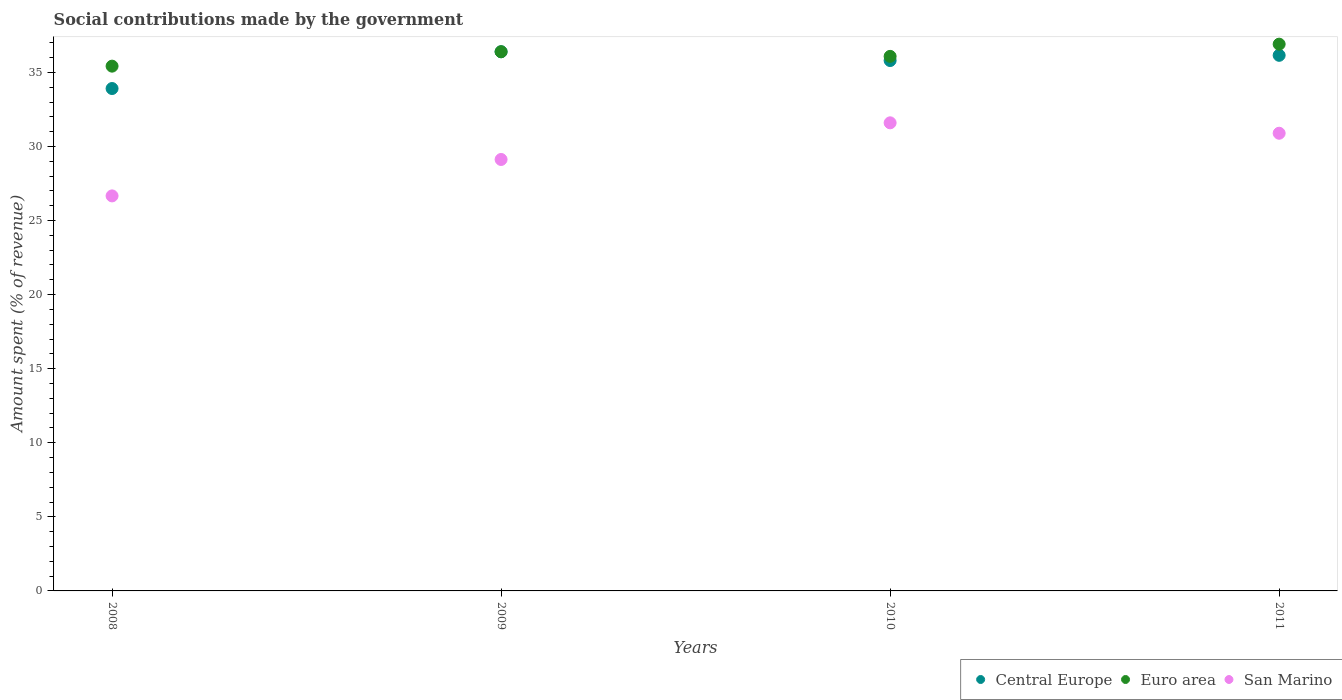What is the amount spent (in %) on social contributions in Central Europe in 2011?
Your answer should be very brief. 36.15. Across all years, what is the maximum amount spent (in %) on social contributions in Euro area?
Keep it short and to the point. 36.9. Across all years, what is the minimum amount spent (in %) on social contributions in Central Europe?
Offer a terse response. 33.91. In which year was the amount spent (in %) on social contributions in Euro area maximum?
Provide a short and direct response. 2011. In which year was the amount spent (in %) on social contributions in Euro area minimum?
Make the answer very short. 2008. What is the total amount spent (in %) on social contributions in Euro area in the graph?
Make the answer very short. 144.8. What is the difference between the amount spent (in %) on social contributions in San Marino in 2009 and that in 2011?
Provide a succinct answer. -1.77. What is the difference between the amount spent (in %) on social contributions in Central Europe in 2011 and the amount spent (in %) on social contributions in Euro area in 2010?
Offer a terse response. 0.07. What is the average amount spent (in %) on social contributions in San Marino per year?
Ensure brevity in your answer.  29.57. In the year 2008, what is the difference between the amount spent (in %) on social contributions in San Marino and amount spent (in %) on social contributions in Central Europe?
Your response must be concise. -7.25. What is the ratio of the amount spent (in %) on social contributions in Euro area in 2009 to that in 2011?
Give a very brief answer. 0.99. Is the amount spent (in %) on social contributions in San Marino in 2010 less than that in 2011?
Make the answer very short. No. Is the difference between the amount spent (in %) on social contributions in San Marino in 2009 and 2011 greater than the difference between the amount spent (in %) on social contributions in Central Europe in 2009 and 2011?
Keep it short and to the point. No. What is the difference between the highest and the second highest amount spent (in %) on social contributions in Euro area?
Offer a terse response. 0.51. What is the difference between the highest and the lowest amount spent (in %) on social contributions in Central Europe?
Make the answer very short. 2.48. Is the sum of the amount spent (in %) on social contributions in Central Europe in 2008 and 2009 greater than the maximum amount spent (in %) on social contributions in Euro area across all years?
Your answer should be very brief. Yes. Does the amount spent (in %) on social contributions in San Marino monotonically increase over the years?
Provide a succinct answer. No. Is the amount spent (in %) on social contributions in Central Europe strictly greater than the amount spent (in %) on social contributions in Euro area over the years?
Offer a very short reply. No. Is the amount spent (in %) on social contributions in Central Europe strictly less than the amount spent (in %) on social contributions in Euro area over the years?
Make the answer very short. No. What is the difference between two consecutive major ticks on the Y-axis?
Offer a terse response. 5. Does the graph contain grids?
Offer a very short reply. No. How many legend labels are there?
Offer a very short reply. 3. What is the title of the graph?
Offer a very short reply. Social contributions made by the government. What is the label or title of the X-axis?
Your answer should be very brief. Years. What is the label or title of the Y-axis?
Give a very brief answer. Amount spent (% of revenue). What is the Amount spent (% of revenue) in Central Europe in 2008?
Your answer should be compact. 33.91. What is the Amount spent (% of revenue) in Euro area in 2008?
Ensure brevity in your answer.  35.42. What is the Amount spent (% of revenue) in San Marino in 2008?
Provide a succinct answer. 26.66. What is the Amount spent (% of revenue) in Central Europe in 2009?
Ensure brevity in your answer.  36.39. What is the Amount spent (% of revenue) in Euro area in 2009?
Ensure brevity in your answer.  36.39. What is the Amount spent (% of revenue) in San Marino in 2009?
Provide a succinct answer. 29.12. What is the Amount spent (% of revenue) of Central Europe in 2010?
Provide a succinct answer. 35.8. What is the Amount spent (% of revenue) in Euro area in 2010?
Provide a short and direct response. 36.08. What is the Amount spent (% of revenue) of San Marino in 2010?
Keep it short and to the point. 31.59. What is the Amount spent (% of revenue) of Central Europe in 2011?
Your answer should be very brief. 36.15. What is the Amount spent (% of revenue) of Euro area in 2011?
Provide a short and direct response. 36.9. What is the Amount spent (% of revenue) in San Marino in 2011?
Ensure brevity in your answer.  30.89. Across all years, what is the maximum Amount spent (% of revenue) in Central Europe?
Ensure brevity in your answer.  36.39. Across all years, what is the maximum Amount spent (% of revenue) of Euro area?
Keep it short and to the point. 36.9. Across all years, what is the maximum Amount spent (% of revenue) of San Marino?
Offer a terse response. 31.59. Across all years, what is the minimum Amount spent (% of revenue) in Central Europe?
Offer a terse response. 33.91. Across all years, what is the minimum Amount spent (% of revenue) in Euro area?
Your answer should be very brief. 35.42. Across all years, what is the minimum Amount spent (% of revenue) of San Marino?
Your answer should be very brief. 26.66. What is the total Amount spent (% of revenue) in Central Europe in the graph?
Ensure brevity in your answer.  142.25. What is the total Amount spent (% of revenue) of Euro area in the graph?
Your answer should be very brief. 144.8. What is the total Amount spent (% of revenue) in San Marino in the graph?
Your response must be concise. 118.27. What is the difference between the Amount spent (% of revenue) in Central Europe in 2008 and that in 2009?
Ensure brevity in your answer.  -2.48. What is the difference between the Amount spent (% of revenue) in Euro area in 2008 and that in 2009?
Your response must be concise. -0.97. What is the difference between the Amount spent (% of revenue) in San Marino in 2008 and that in 2009?
Offer a terse response. -2.46. What is the difference between the Amount spent (% of revenue) in Central Europe in 2008 and that in 2010?
Offer a terse response. -1.89. What is the difference between the Amount spent (% of revenue) of Euro area in 2008 and that in 2010?
Offer a very short reply. -0.66. What is the difference between the Amount spent (% of revenue) in San Marino in 2008 and that in 2010?
Provide a succinct answer. -4.93. What is the difference between the Amount spent (% of revenue) of Central Europe in 2008 and that in 2011?
Make the answer very short. -2.24. What is the difference between the Amount spent (% of revenue) in Euro area in 2008 and that in 2011?
Give a very brief answer. -1.48. What is the difference between the Amount spent (% of revenue) in San Marino in 2008 and that in 2011?
Provide a succinct answer. -4.23. What is the difference between the Amount spent (% of revenue) of Central Europe in 2009 and that in 2010?
Your answer should be compact. 0.59. What is the difference between the Amount spent (% of revenue) of Euro area in 2009 and that in 2010?
Provide a short and direct response. 0.31. What is the difference between the Amount spent (% of revenue) in San Marino in 2009 and that in 2010?
Make the answer very short. -2.47. What is the difference between the Amount spent (% of revenue) of Central Europe in 2009 and that in 2011?
Your answer should be compact. 0.24. What is the difference between the Amount spent (% of revenue) in Euro area in 2009 and that in 2011?
Make the answer very short. -0.51. What is the difference between the Amount spent (% of revenue) of San Marino in 2009 and that in 2011?
Offer a terse response. -1.77. What is the difference between the Amount spent (% of revenue) of Central Europe in 2010 and that in 2011?
Your answer should be very brief. -0.35. What is the difference between the Amount spent (% of revenue) of Euro area in 2010 and that in 2011?
Offer a very short reply. -0.82. What is the difference between the Amount spent (% of revenue) in San Marino in 2010 and that in 2011?
Offer a terse response. 0.7. What is the difference between the Amount spent (% of revenue) of Central Europe in 2008 and the Amount spent (% of revenue) of Euro area in 2009?
Your answer should be compact. -2.48. What is the difference between the Amount spent (% of revenue) of Central Europe in 2008 and the Amount spent (% of revenue) of San Marino in 2009?
Provide a succinct answer. 4.79. What is the difference between the Amount spent (% of revenue) in Euro area in 2008 and the Amount spent (% of revenue) in San Marino in 2009?
Give a very brief answer. 6.3. What is the difference between the Amount spent (% of revenue) of Central Europe in 2008 and the Amount spent (% of revenue) of Euro area in 2010?
Your answer should be very brief. -2.17. What is the difference between the Amount spent (% of revenue) in Central Europe in 2008 and the Amount spent (% of revenue) in San Marino in 2010?
Your response must be concise. 2.31. What is the difference between the Amount spent (% of revenue) in Euro area in 2008 and the Amount spent (% of revenue) in San Marino in 2010?
Make the answer very short. 3.83. What is the difference between the Amount spent (% of revenue) of Central Europe in 2008 and the Amount spent (% of revenue) of Euro area in 2011?
Give a very brief answer. -2.99. What is the difference between the Amount spent (% of revenue) of Central Europe in 2008 and the Amount spent (% of revenue) of San Marino in 2011?
Offer a very short reply. 3.02. What is the difference between the Amount spent (% of revenue) of Euro area in 2008 and the Amount spent (% of revenue) of San Marino in 2011?
Provide a short and direct response. 4.53. What is the difference between the Amount spent (% of revenue) of Central Europe in 2009 and the Amount spent (% of revenue) of Euro area in 2010?
Make the answer very short. 0.31. What is the difference between the Amount spent (% of revenue) in Central Europe in 2009 and the Amount spent (% of revenue) in San Marino in 2010?
Offer a very short reply. 4.8. What is the difference between the Amount spent (% of revenue) of Euro area in 2009 and the Amount spent (% of revenue) of San Marino in 2010?
Offer a terse response. 4.8. What is the difference between the Amount spent (% of revenue) of Central Europe in 2009 and the Amount spent (% of revenue) of Euro area in 2011?
Make the answer very short. -0.51. What is the difference between the Amount spent (% of revenue) of Central Europe in 2009 and the Amount spent (% of revenue) of San Marino in 2011?
Ensure brevity in your answer.  5.5. What is the difference between the Amount spent (% of revenue) of Euro area in 2009 and the Amount spent (% of revenue) of San Marino in 2011?
Keep it short and to the point. 5.5. What is the difference between the Amount spent (% of revenue) in Central Europe in 2010 and the Amount spent (% of revenue) in Euro area in 2011?
Provide a succinct answer. -1.11. What is the difference between the Amount spent (% of revenue) of Central Europe in 2010 and the Amount spent (% of revenue) of San Marino in 2011?
Provide a succinct answer. 4.91. What is the difference between the Amount spent (% of revenue) in Euro area in 2010 and the Amount spent (% of revenue) in San Marino in 2011?
Offer a terse response. 5.19. What is the average Amount spent (% of revenue) of Central Europe per year?
Offer a terse response. 35.56. What is the average Amount spent (% of revenue) of Euro area per year?
Your response must be concise. 36.2. What is the average Amount spent (% of revenue) in San Marino per year?
Make the answer very short. 29.57. In the year 2008, what is the difference between the Amount spent (% of revenue) in Central Europe and Amount spent (% of revenue) in Euro area?
Your response must be concise. -1.51. In the year 2008, what is the difference between the Amount spent (% of revenue) in Central Europe and Amount spent (% of revenue) in San Marino?
Provide a short and direct response. 7.25. In the year 2008, what is the difference between the Amount spent (% of revenue) of Euro area and Amount spent (% of revenue) of San Marino?
Your response must be concise. 8.76. In the year 2009, what is the difference between the Amount spent (% of revenue) in Central Europe and Amount spent (% of revenue) in Euro area?
Your answer should be compact. 0. In the year 2009, what is the difference between the Amount spent (% of revenue) of Central Europe and Amount spent (% of revenue) of San Marino?
Provide a short and direct response. 7.27. In the year 2009, what is the difference between the Amount spent (% of revenue) of Euro area and Amount spent (% of revenue) of San Marino?
Provide a short and direct response. 7.27. In the year 2010, what is the difference between the Amount spent (% of revenue) in Central Europe and Amount spent (% of revenue) in Euro area?
Provide a succinct answer. -0.28. In the year 2010, what is the difference between the Amount spent (% of revenue) of Central Europe and Amount spent (% of revenue) of San Marino?
Your answer should be compact. 4.2. In the year 2010, what is the difference between the Amount spent (% of revenue) in Euro area and Amount spent (% of revenue) in San Marino?
Offer a terse response. 4.49. In the year 2011, what is the difference between the Amount spent (% of revenue) of Central Europe and Amount spent (% of revenue) of Euro area?
Keep it short and to the point. -0.75. In the year 2011, what is the difference between the Amount spent (% of revenue) of Central Europe and Amount spent (% of revenue) of San Marino?
Keep it short and to the point. 5.26. In the year 2011, what is the difference between the Amount spent (% of revenue) of Euro area and Amount spent (% of revenue) of San Marino?
Ensure brevity in your answer.  6.01. What is the ratio of the Amount spent (% of revenue) in Central Europe in 2008 to that in 2009?
Provide a succinct answer. 0.93. What is the ratio of the Amount spent (% of revenue) of Euro area in 2008 to that in 2009?
Give a very brief answer. 0.97. What is the ratio of the Amount spent (% of revenue) in San Marino in 2008 to that in 2009?
Provide a succinct answer. 0.92. What is the ratio of the Amount spent (% of revenue) in Central Europe in 2008 to that in 2010?
Ensure brevity in your answer.  0.95. What is the ratio of the Amount spent (% of revenue) in Euro area in 2008 to that in 2010?
Offer a very short reply. 0.98. What is the ratio of the Amount spent (% of revenue) in San Marino in 2008 to that in 2010?
Provide a short and direct response. 0.84. What is the ratio of the Amount spent (% of revenue) of Central Europe in 2008 to that in 2011?
Provide a succinct answer. 0.94. What is the ratio of the Amount spent (% of revenue) of Euro area in 2008 to that in 2011?
Ensure brevity in your answer.  0.96. What is the ratio of the Amount spent (% of revenue) of San Marino in 2008 to that in 2011?
Offer a very short reply. 0.86. What is the ratio of the Amount spent (% of revenue) in Central Europe in 2009 to that in 2010?
Provide a succinct answer. 1.02. What is the ratio of the Amount spent (% of revenue) in Euro area in 2009 to that in 2010?
Provide a succinct answer. 1.01. What is the ratio of the Amount spent (% of revenue) of San Marino in 2009 to that in 2010?
Make the answer very short. 0.92. What is the ratio of the Amount spent (% of revenue) in Euro area in 2009 to that in 2011?
Keep it short and to the point. 0.99. What is the ratio of the Amount spent (% of revenue) in San Marino in 2009 to that in 2011?
Keep it short and to the point. 0.94. What is the ratio of the Amount spent (% of revenue) of Central Europe in 2010 to that in 2011?
Provide a succinct answer. 0.99. What is the ratio of the Amount spent (% of revenue) of Euro area in 2010 to that in 2011?
Offer a very short reply. 0.98. What is the ratio of the Amount spent (% of revenue) of San Marino in 2010 to that in 2011?
Ensure brevity in your answer.  1.02. What is the difference between the highest and the second highest Amount spent (% of revenue) in Central Europe?
Ensure brevity in your answer.  0.24. What is the difference between the highest and the second highest Amount spent (% of revenue) in Euro area?
Offer a very short reply. 0.51. What is the difference between the highest and the second highest Amount spent (% of revenue) of San Marino?
Keep it short and to the point. 0.7. What is the difference between the highest and the lowest Amount spent (% of revenue) of Central Europe?
Provide a short and direct response. 2.48. What is the difference between the highest and the lowest Amount spent (% of revenue) in Euro area?
Provide a short and direct response. 1.48. What is the difference between the highest and the lowest Amount spent (% of revenue) of San Marino?
Your answer should be very brief. 4.93. 